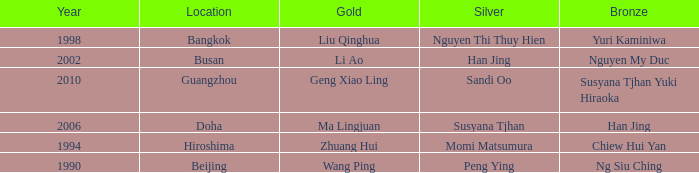What Silver has the Location of Guangzhou? Sandi Oo. 